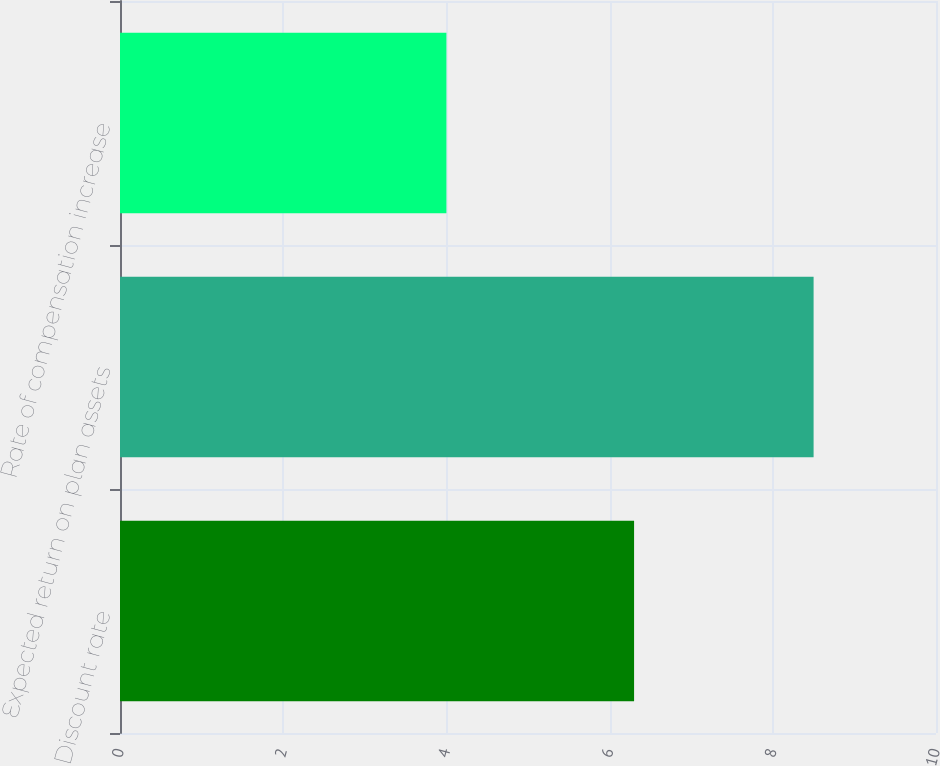<chart> <loc_0><loc_0><loc_500><loc_500><bar_chart><fcel>Discount rate<fcel>Expected return on plan assets<fcel>Rate of compensation increase<nl><fcel>6.3<fcel>8.5<fcel>4<nl></chart> 